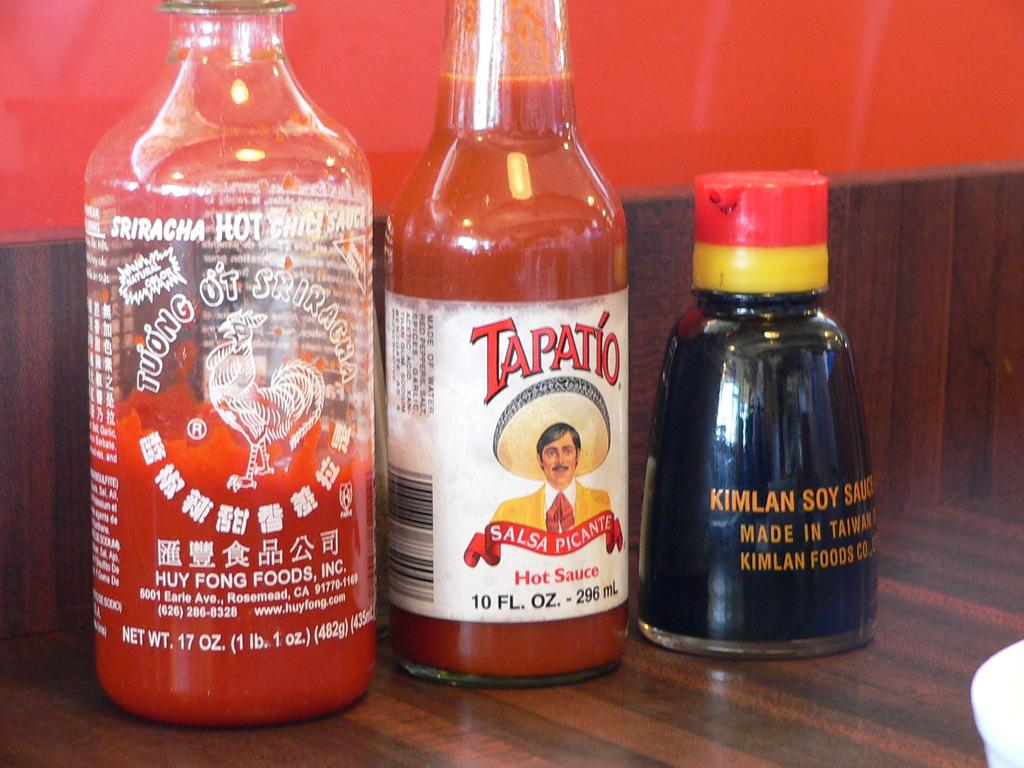How many bottles are visible in the image? There are three bottles in the image. What is inside the bottles? The bottles contain drinks. Are there any decorations or markings on the bottles? Yes, there are stickers on the bottles. What type of surface are the bottles placed on? The bottles are placed on a wooden floor. What type of society is depicted in the image? There is no society depicted in the image; it only shows three bottles with drinks and stickers on a wooden floor. 